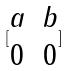Convert formula to latex. <formula><loc_0><loc_0><loc_500><loc_500>[ \begin{matrix} a & b \\ 0 & 0 \end{matrix} ]</formula> 